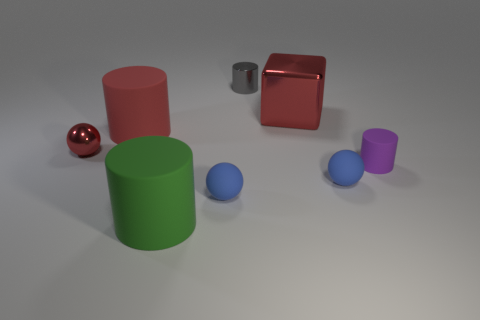There is a large thing that is the same color as the metallic cube; what material is it?
Offer a very short reply. Rubber. Is the metallic block the same color as the small metal ball?
Keep it short and to the point. Yes. Do the big object that is to the right of the tiny metal cylinder and the tiny shiny sphere have the same color?
Your answer should be very brief. Yes. What color is the tiny cylinder in front of the small gray cylinder?
Your answer should be very brief. Purple. Is the number of things that are in front of the small red metal ball greater than the number of red cubes?
Your answer should be very brief. Yes. What number of other things are there of the same size as the red sphere?
Your answer should be compact. 4. There is a green object; how many small balls are on the right side of it?
Ensure brevity in your answer.  2. Are there the same number of tiny red objects behind the tiny shiny ball and red metal spheres that are behind the large shiny cube?
Offer a very short reply. Yes. The green object that is the same shape as the small purple rubber thing is what size?
Provide a succinct answer. Large. There is a red metal object that is behind the metal ball; what shape is it?
Give a very brief answer. Cube. 